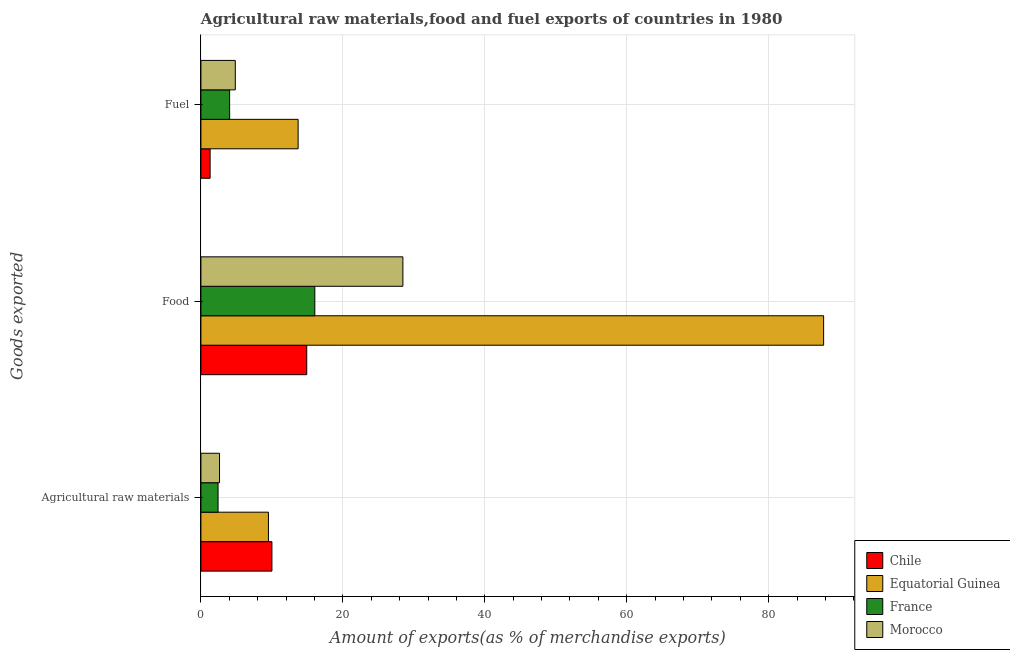How many different coloured bars are there?
Make the answer very short. 4. How many bars are there on the 3rd tick from the top?
Keep it short and to the point. 4. How many bars are there on the 3rd tick from the bottom?
Your answer should be very brief. 4. What is the label of the 2nd group of bars from the top?
Your answer should be very brief. Food. What is the percentage of fuel exports in France?
Ensure brevity in your answer.  4.05. Across all countries, what is the maximum percentage of food exports?
Keep it short and to the point. 87.75. Across all countries, what is the minimum percentage of raw materials exports?
Offer a terse response. 2.42. In which country was the percentage of raw materials exports maximum?
Give a very brief answer. Chile. What is the total percentage of raw materials exports in the graph?
Offer a terse response. 24.56. What is the difference between the percentage of food exports in Chile and that in France?
Provide a short and direct response. -1.14. What is the difference between the percentage of raw materials exports in Morocco and the percentage of fuel exports in Equatorial Guinea?
Make the answer very short. -11.08. What is the average percentage of raw materials exports per country?
Provide a short and direct response. 6.14. What is the difference between the percentage of fuel exports and percentage of food exports in Chile?
Your answer should be compact. -13.62. In how many countries, is the percentage of food exports greater than 44 %?
Keep it short and to the point. 1. What is the ratio of the percentage of raw materials exports in Equatorial Guinea to that in Morocco?
Provide a short and direct response. 3.63. Is the difference between the percentage of fuel exports in Chile and Equatorial Guinea greater than the difference between the percentage of food exports in Chile and Equatorial Guinea?
Offer a very short reply. Yes. What is the difference between the highest and the second highest percentage of food exports?
Make the answer very short. 59.29. What is the difference between the highest and the lowest percentage of raw materials exports?
Keep it short and to the point. 7.59. In how many countries, is the percentage of raw materials exports greater than the average percentage of raw materials exports taken over all countries?
Ensure brevity in your answer.  2. What does the 1st bar from the top in Agricultural raw materials represents?
Give a very brief answer. Morocco. What does the 4th bar from the bottom in Food represents?
Give a very brief answer. Morocco. Are all the bars in the graph horizontal?
Provide a succinct answer. Yes. What is the difference between two consecutive major ticks on the X-axis?
Your answer should be compact. 20. Where does the legend appear in the graph?
Provide a succinct answer. Bottom right. How many legend labels are there?
Your answer should be compact. 4. What is the title of the graph?
Keep it short and to the point. Agricultural raw materials,food and fuel exports of countries in 1980. What is the label or title of the X-axis?
Your answer should be very brief. Amount of exports(as % of merchandise exports). What is the label or title of the Y-axis?
Make the answer very short. Goods exported. What is the Amount of exports(as % of merchandise exports) of Chile in Agricultural raw materials?
Provide a short and direct response. 10.01. What is the Amount of exports(as % of merchandise exports) in Equatorial Guinea in Agricultural raw materials?
Your answer should be compact. 9.51. What is the Amount of exports(as % of merchandise exports) in France in Agricultural raw materials?
Give a very brief answer. 2.42. What is the Amount of exports(as % of merchandise exports) in Morocco in Agricultural raw materials?
Keep it short and to the point. 2.62. What is the Amount of exports(as % of merchandise exports) in Chile in Food?
Give a very brief answer. 14.91. What is the Amount of exports(as % of merchandise exports) in Equatorial Guinea in Food?
Provide a succinct answer. 87.75. What is the Amount of exports(as % of merchandise exports) of France in Food?
Provide a short and direct response. 16.05. What is the Amount of exports(as % of merchandise exports) in Morocco in Food?
Provide a succinct answer. 28.46. What is the Amount of exports(as % of merchandise exports) in Chile in Fuel?
Your answer should be very brief. 1.3. What is the Amount of exports(as % of merchandise exports) in Equatorial Guinea in Fuel?
Your response must be concise. 13.7. What is the Amount of exports(as % of merchandise exports) of France in Fuel?
Keep it short and to the point. 4.05. What is the Amount of exports(as % of merchandise exports) of Morocco in Fuel?
Your answer should be compact. 4.85. Across all Goods exported, what is the maximum Amount of exports(as % of merchandise exports) in Chile?
Ensure brevity in your answer.  14.91. Across all Goods exported, what is the maximum Amount of exports(as % of merchandise exports) in Equatorial Guinea?
Your response must be concise. 87.75. Across all Goods exported, what is the maximum Amount of exports(as % of merchandise exports) of France?
Offer a terse response. 16.05. Across all Goods exported, what is the maximum Amount of exports(as % of merchandise exports) of Morocco?
Make the answer very short. 28.46. Across all Goods exported, what is the minimum Amount of exports(as % of merchandise exports) of Chile?
Offer a terse response. 1.3. Across all Goods exported, what is the minimum Amount of exports(as % of merchandise exports) in Equatorial Guinea?
Provide a succinct answer. 9.51. Across all Goods exported, what is the minimum Amount of exports(as % of merchandise exports) in France?
Keep it short and to the point. 2.42. Across all Goods exported, what is the minimum Amount of exports(as % of merchandise exports) in Morocco?
Your answer should be very brief. 2.62. What is the total Amount of exports(as % of merchandise exports) in Chile in the graph?
Provide a short and direct response. 26.21. What is the total Amount of exports(as % of merchandise exports) in Equatorial Guinea in the graph?
Make the answer very short. 110.97. What is the total Amount of exports(as % of merchandise exports) in France in the graph?
Give a very brief answer. 22.51. What is the total Amount of exports(as % of merchandise exports) of Morocco in the graph?
Offer a very short reply. 35.93. What is the difference between the Amount of exports(as % of merchandise exports) of Chile in Agricultural raw materials and that in Food?
Provide a succinct answer. -4.9. What is the difference between the Amount of exports(as % of merchandise exports) in Equatorial Guinea in Agricultural raw materials and that in Food?
Ensure brevity in your answer.  -78.24. What is the difference between the Amount of exports(as % of merchandise exports) of France in Agricultural raw materials and that in Food?
Your response must be concise. -13.64. What is the difference between the Amount of exports(as % of merchandise exports) of Morocco in Agricultural raw materials and that in Food?
Make the answer very short. -25.84. What is the difference between the Amount of exports(as % of merchandise exports) in Chile in Agricultural raw materials and that in Fuel?
Make the answer very short. 8.71. What is the difference between the Amount of exports(as % of merchandise exports) in Equatorial Guinea in Agricultural raw materials and that in Fuel?
Your answer should be very brief. -4.18. What is the difference between the Amount of exports(as % of merchandise exports) of France in Agricultural raw materials and that in Fuel?
Your response must be concise. -1.63. What is the difference between the Amount of exports(as % of merchandise exports) of Morocco in Agricultural raw materials and that in Fuel?
Offer a terse response. -2.22. What is the difference between the Amount of exports(as % of merchandise exports) in Chile in Food and that in Fuel?
Provide a succinct answer. 13.62. What is the difference between the Amount of exports(as % of merchandise exports) of Equatorial Guinea in Food and that in Fuel?
Provide a succinct answer. 74.05. What is the difference between the Amount of exports(as % of merchandise exports) in France in Food and that in Fuel?
Keep it short and to the point. 12.01. What is the difference between the Amount of exports(as % of merchandise exports) of Morocco in Food and that in Fuel?
Your answer should be compact. 23.62. What is the difference between the Amount of exports(as % of merchandise exports) of Chile in Agricultural raw materials and the Amount of exports(as % of merchandise exports) of Equatorial Guinea in Food?
Ensure brevity in your answer.  -77.74. What is the difference between the Amount of exports(as % of merchandise exports) of Chile in Agricultural raw materials and the Amount of exports(as % of merchandise exports) of France in Food?
Your answer should be compact. -6.04. What is the difference between the Amount of exports(as % of merchandise exports) in Chile in Agricultural raw materials and the Amount of exports(as % of merchandise exports) in Morocco in Food?
Your response must be concise. -18.45. What is the difference between the Amount of exports(as % of merchandise exports) in Equatorial Guinea in Agricultural raw materials and the Amount of exports(as % of merchandise exports) in France in Food?
Your response must be concise. -6.54. What is the difference between the Amount of exports(as % of merchandise exports) of Equatorial Guinea in Agricultural raw materials and the Amount of exports(as % of merchandise exports) of Morocco in Food?
Your response must be concise. -18.95. What is the difference between the Amount of exports(as % of merchandise exports) of France in Agricultural raw materials and the Amount of exports(as % of merchandise exports) of Morocco in Food?
Offer a terse response. -26.05. What is the difference between the Amount of exports(as % of merchandise exports) in Chile in Agricultural raw materials and the Amount of exports(as % of merchandise exports) in Equatorial Guinea in Fuel?
Keep it short and to the point. -3.69. What is the difference between the Amount of exports(as % of merchandise exports) of Chile in Agricultural raw materials and the Amount of exports(as % of merchandise exports) of France in Fuel?
Offer a very short reply. 5.96. What is the difference between the Amount of exports(as % of merchandise exports) of Chile in Agricultural raw materials and the Amount of exports(as % of merchandise exports) of Morocco in Fuel?
Keep it short and to the point. 5.16. What is the difference between the Amount of exports(as % of merchandise exports) of Equatorial Guinea in Agricultural raw materials and the Amount of exports(as % of merchandise exports) of France in Fuel?
Provide a short and direct response. 5.47. What is the difference between the Amount of exports(as % of merchandise exports) in Equatorial Guinea in Agricultural raw materials and the Amount of exports(as % of merchandise exports) in Morocco in Fuel?
Keep it short and to the point. 4.67. What is the difference between the Amount of exports(as % of merchandise exports) in France in Agricultural raw materials and the Amount of exports(as % of merchandise exports) in Morocco in Fuel?
Your response must be concise. -2.43. What is the difference between the Amount of exports(as % of merchandise exports) of Chile in Food and the Amount of exports(as % of merchandise exports) of Equatorial Guinea in Fuel?
Your answer should be compact. 1.21. What is the difference between the Amount of exports(as % of merchandise exports) in Chile in Food and the Amount of exports(as % of merchandise exports) in France in Fuel?
Your response must be concise. 10.87. What is the difference between the Amount of exports(as % of merchandise exports) of Chile in Food and the Amount of exports(as % of merchandise exports) of Morocco in Fuel?
Offer a terse response. 10.07. What is the difference between the Amount of exports(as % of merchandise exports) of Equatorial Guinea in Food and the Amount of exports(as % of merchandise exports) of France in Fuel?
Offer a very short reply. 83.71. What is the difference between the Amount of exports(as % of merchandise exports) in Equatorial Guinea in Food and the Amount of exports(as % of merchandise exports) in Morocco in Fuel?
Offer a very short reply. 82.91. What is the difference between the Amount of exports(as % of merchandise exports) in France in Food and the Amount of exports(as % of merchandise exports) in Morocco in Fuel?
Ensure brevity in your answer.  11.21. What is the average Amount of exports(as % of merchandise exports) in Chile per Goods exported?
Provide a short and direct response. 8.74. What is the average Amount of exports(as % of merchandise exports) of Equatorial Guinea per Goods exported?
Provide a succinct answer. 36.99. What is the average Amount of exports(as % of merchandise exports) in France per Goods exported?
Your answer should be very brief. 7.5. What is the average Amount of exports(as % of merchandise exports) of Morocco per Goods exported?
Provide a short and direct response. 11.98. What is the difference between the Amount of exports(as % of merchandise exports) in Chile and Amount of exports(as % of merchandise exports) in Equatorial Guinea in Agricultural raw materials?
Ensure brevity in your answer.  0.49. What is the difference between the Amount of exports(as % of merchandise exports) in Chile and Amount of exports(as % of merchandise exports) in France in Agricultural raw materials?
Provide a short and direct response. 7.59. What is the difference between the Amount of exports(as % of merchandise exports) of Chile and Amount of exports(as % of merchandise exports) of Morocco in Agricultural raw materials?
Your response must be concise. 7.38. What is the difference between the Amount of exports(as % of merchandise exports) of Equatorial Guinea and Amount of exports(as % of merchandise exports) of France in Agricultural raw materials?
Keep it short and to the point. 7.1. What is the difference between the Amount of exports(as % of merchandise exports) in Equatorial Guinea and Amount of exports(as % of merchandise exports) in Morocco in Agricultural raw materials?
Make the answer very short. 6.89. What is the difference between the Amount of exports(as % of merchandise exports) in France and Amount of exports(as % of merchandise exports) in Morocco in Agricultural raw materials?
Your answer should be very brief. -0.21. What is the difference between the Amount of exports(as % of merchandise exports) of Chile and Amount of exports(as % of merchandise exports) of Equatorial Guinea in Food?
Offer a very short reply. -72.84. What is the difference between the Amount of exports(as % of merchandise exports) in Chile and Amount of exports(as % of merchandise exports) in France in Food?
Your response must be concise. -1.14. What is the difference between the Amount of exports(as % of merchandise exports) in Chile and Amount of exports(as % of merchandise exports) in Morocco in Food?
Provide a succinct answer. -13.55. What is the difference between the Amount of exports(as % of merchandise exports) in Equatorial Guinea and Amount of exports(as % of merchandise exports) in France in Food?
Make the answer very short. 71.7. What is the difference between the Amount of exports(as % of merchandise exports) in Equatorial Guinea and Amount of exports(as % of merchandise exports) in Morocco in Food?
Offer a very short reply. 59.29. What is the difference between the Amount of exports(as % of merchandise exports) of France and Amount of exports(as % of merchandise exports) of Morocco in Food?
Your answer should be compact. -12.41. What is the difference between the Amount of exports(as % of merchandise exports) in Chile and Amount of exports(as % of merchandise exports) in Equatorial Guinea in Fuel?
Your answer should be compact. -12.4. What is the difference between the Amount of exports(as % of merchandise exports) of Chile and Amount of exports(as % of merchandise exports) of France in Fuel?
Ensure brevity in your answer.  -2.75. What is the difference between the Amount of exports(as % of merchandise exports) of Chile and Amount of exports(as % of merchandise exports) of Morocco in Fuel?
Give a very brief answer. -3.55. What is the difference between the Amount of exports(as % of merchandise exports) of Equatorial Guinea and Amount of exports(as % of merchandise exports) of France in Fuel?
Provide a short and direct response. 9.65. What is the difference between the Amount of exports(as % of merchandise exports) of Equatorial Guinea and Amount of exports(as % of merchandise exports) of Morocco in Fuel?
Your answer should be very brief. 8.85. What is the difference between the Amount of exports(as % of merchandise exports) in France and Amount of exports(as % of merchandise exports) in Morocco in Fuel?
Give a very brief answer. -0.8. What is the ratio of the Amount of exports(as % of merchandise exports) of Chile in Agricultural raw materials to that in Food?
Make the answer very short. 0.67. What is the ratio of the Amount of exports(as % of merchandise exports) in Equatorial Guinea in Agricultural raw materials to that in Food?
Your response must be concise. 0.11. What is the ratio of the Amount of exports(as % of merchandise exports) of France in Agricultural raw materials to that in Food?
Keep it short and to the point. 0.15. What is the ratio of the Amount of exports(as % of merchandise exports) of Morocco in Agricultural raw materials to that in Food?
Keep it short and to the point. 0.09. What is the ratio of the Amount of exports(as % of merchandise exports) of Chile in Agricultural raw materials to that in Fuel?
Provide a short and direct response. 7.72. What is the ratio of the Amount of exports(as % of merchandise exports) in Equatorial Guinea in Agricultural raw materials to that in Fuel?
Keep it short and to the point. 0.69. What is the ratio of the Amount of exports(as % of merchandise exports) in France in Agricultural raw materials to that in Fuel?
Ensure brevity in your answer.  0.6. What is the ratio of the Amount of exports(as % of merchandise exports) of Morocco in Agricultural raw materials to that in Fuel?
Make the answer very short. 0.54. What is the ratio of the Amount of exports(as % of merchandise exports) in Chile in Food to that in Fuel?
Offer a very short reply. 11.51. What is the ratio of the Amount of exports(as % of merchandise exports) in Equatorial Guinea in Food to that in Fuel?
Provide a succinct answer. 6.41. What is the ratio of the Amount of exports(as % of merchandise exports) in France in Food to that in Fuel?
Your answer should be very brief. 3.97. What is the ratio of the Amount of exports(as % of merchandise exports) in Morocco in Food to that in Fuel?
Offer a very short reply. 5.87. What is the difference between the highest and the second highest Amount of exports(as % of merchandise exports) in Chile?
Offer a very short reply. 4.9. What is the difference between the highest and the second highest Amount of exports(as % of merchandise exports) of Equatorial Guinea?
Provide a short and direct response. 74.05. What is the difference between the highest and the second highest Amount of exports(as % of merchandise exports) of France?
Offer a very short reply. 12.01. What is the difference between the highest and the second highest Amount of exports(as % of merchandise exports) of Morocco?
Provide a short and direct response. 23.62. What is the difference between the highest and the lowest Amount of exports(as % of merchandise exports) in Chile?
Your answer should be compact. 13.62. What is the difference between the highest and the lowest Amount of exports(as % of merchandise exports) in Equatorial Guinea?
Your answer should be compact. 78.24. What is the difference between the highest and the lowest Amount of exports(as % of merchandise exports) of France?
Make the answer very short. 13.64. What is the difference between the highest and the lowest Amount of exports(as % of merchandise exports) of Morocco?
Provide a succinct answer. 25.84. 